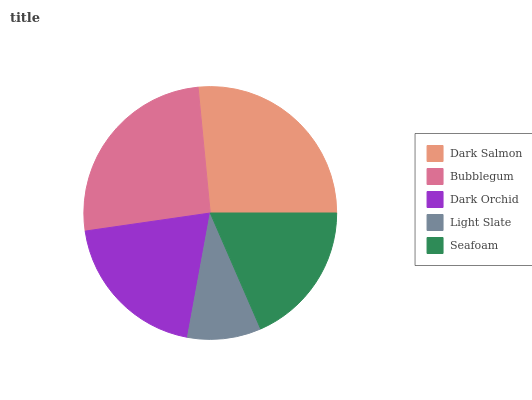Is Light Slate the minimum?
Answer yes or no. Yes. Is Dark Salmon the maximum?
Answer yes or no. Yes. Is Bubblegum the minimum?
Answer yes or no. No. Is Bubblegum the maximum?
Answer yes or no. No. Is Dark Salmon greater than Bubblegum?
Answer yes or no. Yes. Is Bubblegum less than Dark Salmon?
Answer yes or no. Yes. Is Bubblegum greater than Dark Salmon?
Answer yes or no. No. Is Dark Salmon less than Bubblegum?
Answer yes or no. No. Is Dark Orchid the high median?
Answer yes or no. Yes. Is Dark Orchid the low median?
Answer yes or no. Yes. Is Light Slate the high median?
Answer yes or no. No. Is Bubblegum the low median?
Answer yes or no. No. 